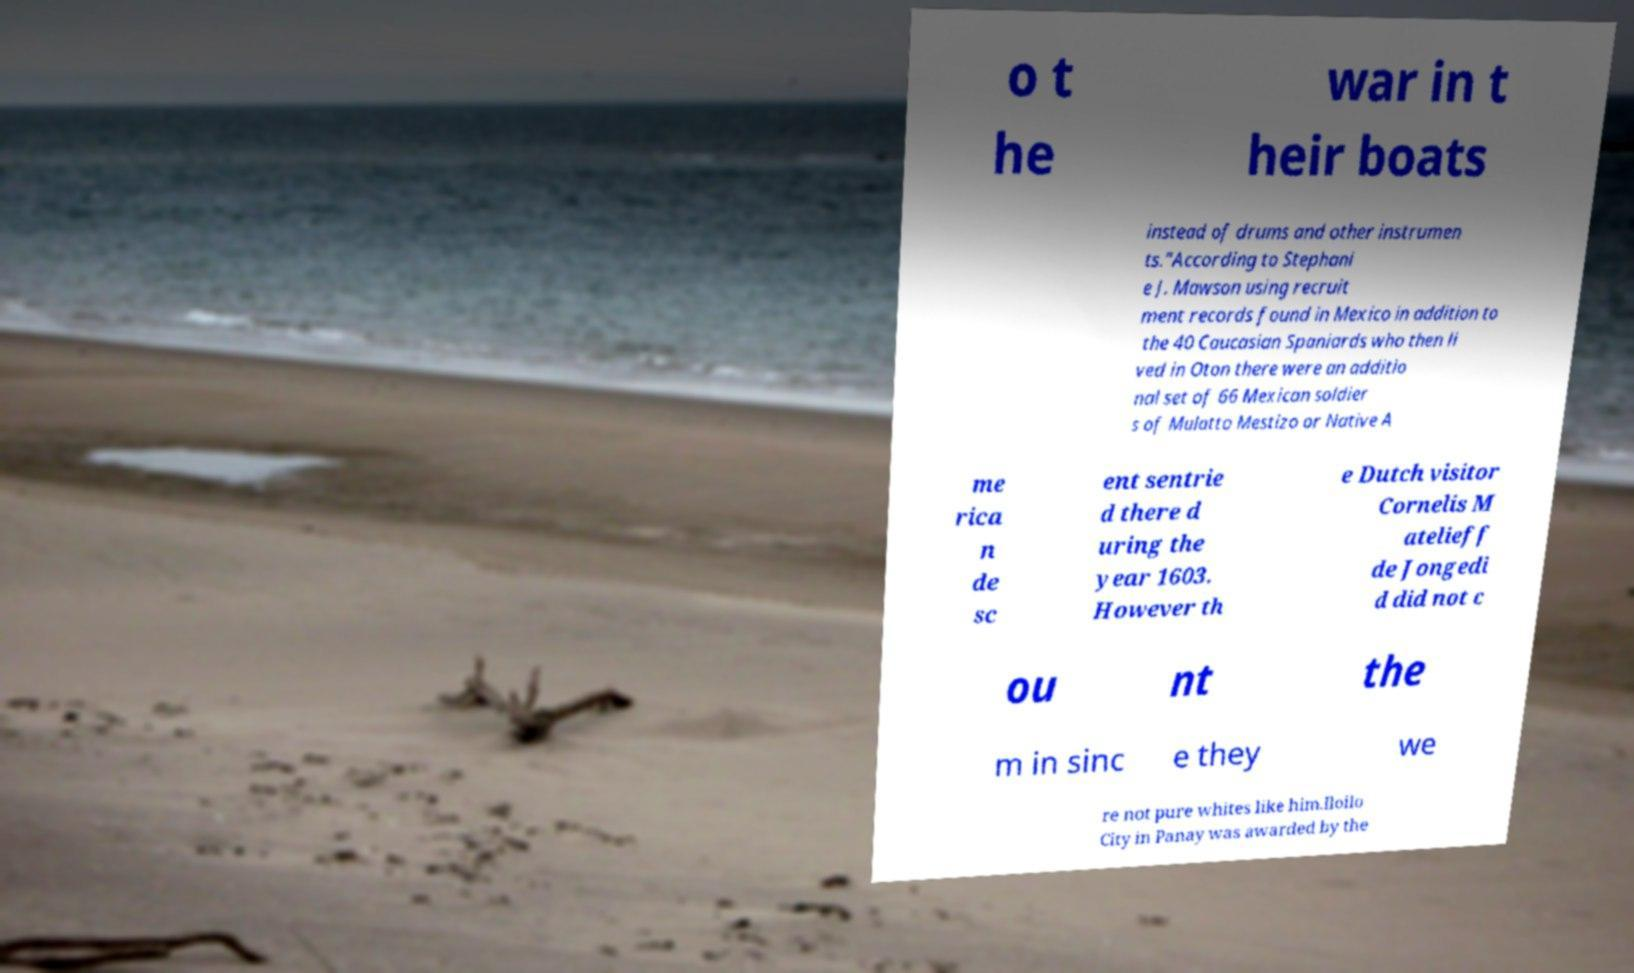Please identify and transcribe the text found in this image. o t he war in t heir boats instead of drums and other instrumen ts."According to Stephani e J. Mawson using recruit ment records found in Mexico in addition to the 40 Caucasian Spaniards who then li ved in Oton there were an additio nal set of 66 Mexican soldier s of Mulatto Mestizo or Native A me rica n de sc ent sentrie d there d uring the year 1603. However th e Dutch visitor Cornelis M atelieff de Jongedi d did not c ou nt the m in sinc e they we re not pure whites like him.Iloilo City in Panay was awarded by the 